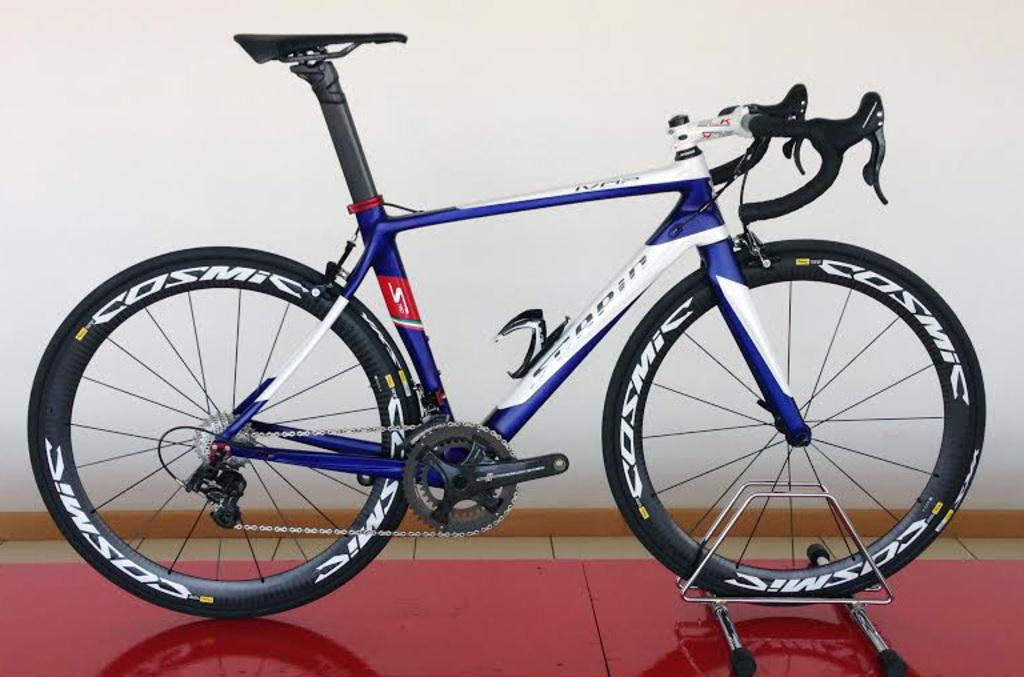What is placed on the floor in the image? There is a bicycle placed on the floor. Is the bicycle accompanied by any other objects or figures? The image only shows a bicycle placed on the floor. Absurd Question/Answer: What type of answer can be seen on the needle in the image? There is no needle or answer present in the image, as it features a bicycle placed on the floor. What type of jam is being used to fix the bicycle in the image? There is no jam or indication of repair in the image; it simply shows a bicycle placed on the floor. 